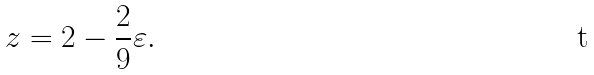<formula> <loc_0><loc_0><loc_500><loc_500>z = 2 - \frac { 2 } { 9 } \varepsilon .</formula> 